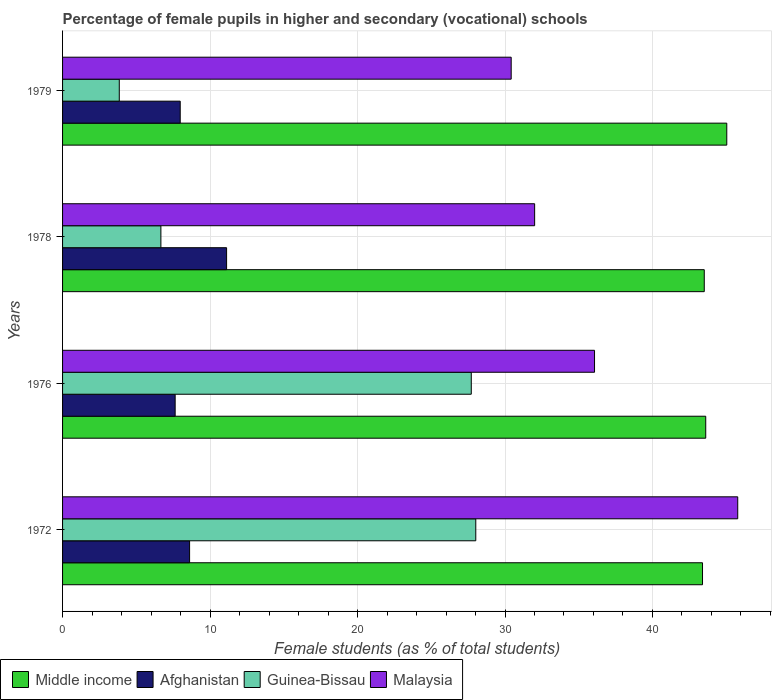Are the number of bars per tick equal to the number of legend labels?
Offer a very short reply. Yes. How many bars are there on the 4th tick from the bottom?
Provide a succinct answer. 4. What is the label of the 3rd group of bars from the top?
Offer a very short reply. 1976. In how many cases, is the number of bars for a given year not equal to the number of legend labels?
Ensure brevity in your answer.  0. What is the percentage of female pupils in higher and secondary schools in Middle income in 1976?
Offer a very short reply. 43.61. Across all years, what is the maximum percentage of female pupils in higher and secondary schools in Guinea-Bissau?
Offer a very short reply. 28.02. Across all years, what is the minimum percentage of female pupils in higher and secondary schools in Middle income?
Your response must be concise. 43.39. In which year was the percentage of female pupils in higher and secondary schools in Middle income maximum?
Your answer should be very brief. 1979. In which year was the percentage of female pupils in higher and secondary schools in Afghanistan minimum?
Provide a short and direct response. 1976. What is the total percentage of female pupils in higher and secondary schools in Malaysia in the graph?
Ensure brevity in your answer.  144.28. What is the difference between the percentage of female pupils in higher and secondary schools in Guinea-Bissau in 1972 and that in 1976?
Your answer should be compact. 0.31. What is the difference between the percentage of female pupils in higher and secondary schools in Guinea-Bissau in 1976 and the percentage of female pupils in higher and secondary schools in Afghanistan in 1972?
Your response must be concise. 19.1. What is the average percentage of female pupils in higher and secondary schools in Middle income per year?
Ensure brevity in your answer.  43.89. In the year 1978, what is the difference between the percentage of female pupils in higher and secondary schools in Middle income and percentage of female pupils in higher and secondary schools in Afghanistan?
Provide a succinct answer. 32.39. What is the ratio of the percentage of female pupils in higher and secondary schools in Guinea-Bissau in 1972 to that in 1978?
Keep it short and to the point. 4.2. Is the percentage of female pupils in higher and secondary schools in Malaysia in 1978 less than that in 1979?
Provide a short and direct response. No. Is the difference between the percentage of female pupils in higher and secondary schools in Middle income in 1972 and 1976 greater than the difference between the percentage of female pupils in higher and secondary schools in Afghanistan in 1972 and 1976?
Your response must be concise. No. What is the difference between the highest and the second highest percentage of female pupils in higher and secondary schools in Afghanistan?
Your answer should be compact. 2.51. What is the difference between the highest and the lowest percentage of female pupils in higher and secondary schools in Guinea-Bissau?
Keep it short and to the point. 24.17. In how many years, is the percentage of female pupils in higher and secondary schools in Malaysia greater than the average percentage of female pupils in higher and secondary schools in Malaysia taken over all years?
Your answer should be very brief. 2. Is the sum of the percentage of female pupils in higher and secondary schools in Malaysia in 1972 and 1976 greater than the maximum percentage of female pupils in higher and secondary schools in Guinea-Bissau across all years?
Offer a very short reply. Yes. Is it the case that in every year, the sum of the percentage of female pupils in higher and secondary schools in Guinea-Bissau and percentage of female pupils in higher and secondary schools in Afghanistan is greater than the sum of percentage of female pupils in higher and secondary schools in Malaysia and percentage of female pupils in higher and secondary schools in Middle income?
Offer a terse response. No. What does the 3rd bar from the top in 1972 represents?
Provide a short and direct response. Afghanistan. What does the 2nd bar from the bottom in 1979 represents?
Provide a succinct answer. Afghanistan. How many bars are there?
Your answer should be very brief. 16. What is the difference between two consecutive major ticks on the X-axis?
Give a very brief answer. 10. Does the graph contain grids?
Provide a succinct answer. Yes. How many legend labels are there?
Your answer should be very brief. 4. How are the legend labels stacked?
Offer a terse response. Horizontal. What is the title of the graph?
Offer a very short reply. Percentage of female pupils in higher and secondary (vocational) schools. Does "Tuvalu" appear as one of the legend labels in the graph?
Your answer should be very brief. No. What is the label or title of the X-axis?
Your answer should be compact. Female students (as % of total students). What is the label or title of the Y-axis?
Ensure brevity in your answer.  Years. What is the Female students (as % of total students) of Middle income in 1972?
Provide a short and direct response. 43.39. What is the Female students (as % of total students) in Afghanistan in 1972?
Ensure brevity in your answer.  8.61. What is the Female students (as % of total students) of Guinea-Bissau in 1972?
Make the answer very short. 28.02. What is the Female students (as % of total students) of Malaysia in 1972?
Your answer should be very brief. 45.78. What is the Female students (as % of total students) of Middle income in 1976?
Offer a very short reply. 43.61. What is the Female students (as % of total students) of Afghanistan in 1976?
Your answer should be compact. 7.63. What is the Female students (as % of total students) in Guinea-Bissau in 1976?
Your answer should be very brief. 27.71. What is the Female students (as % of total students) of Malaysia in 1976?
Give a very brief answer. 36.07. What is the Female students (as % of total students) in Middle income in 1978?
Give a very brief answer. 43.51. What is the Female students (as % of total students) of Afghanistan in 1978?
Keep it short and to the point. 11.12. What is the Female students (as % of total students) in Guinea-Bissau in 1978?
Offer a terse response. 6.67. What is the Female students (as % of total students) in Malaysia in 1978?
Give a very brief answer. 32.01. What is the Female students (as % of total students) of Middle income in 1979?
Offer a terse response. 45.04. What is the Female students (as % of total students) of Afghanistan in 1979?
Offer a terse response. 7.98. What is the Female students (as % of total students) in Guinea-Bissau in 1979?
Ensure brevity in your answer.  3.85. What is the Female students (as % of total students) of Malaysia in 1979?
Keep it short and to the point. 30.42. Across all years, what is the maximum Female students (as % of total students) of Middle income?
Give a very brief answer. 45.04. Across all years, what is the maximum Female students (as % of total students) in Afghanistan?
Provide a succinct answer. 11.12. Across all years, what is the maximum Female students (as % of total students) of Guinea-Bissau?
Offer a very short reply. 28.02. Across all years, what is the maximum Female students (as % of total students) of Malaysia?
Offer a terse response. 45.78. Across all years, what is the minimum Female students (as % of total students) of Middle income?
Provide a short and direct response. 43.39. Across all years, what is the minimum Female students (as % of total students) of Afghanistan?
Provide a short and direct response. 7.63. Across all years, what is the minimum Female students (as % of total students) in Guinea-Bissau?
Your answer should be compact. 3.85. Across all years, what is the minimum Female students (as % of total students) in Malaysia?
Offer a very short reply. 30.42. What is the total Female students (as % of total students) of Middle income in the graph?
Your answer should be compact. 175.56. What is the total Female students (as % of total students) in Afghanistan in the graph?
Keep it short and to the point. 35.35. What is the total Female students (as % of total students) of Guinea-Bissau in the graph?
Offer a terse response. 66.25. What is the total Female students (as % of total students) in Malaysia in the graph?
Provide a succinct answer. 144.28. What is the difference between the Female students (as % of total students) in Middle income in 1972 and that in 1976?
Keep it short and to the point. -0.22. What is the difference between the Female students (as % of total students) in Afghanistan in 1972 and that in 1976?
Make the answer very short. 0.98. What is the difference between the Female students (as % of total students) of Guinea-Bissau in 1972 and that in 1976?
Offer a terse response. 0.31. What is the difference between the Female students (as % of total students) in Malaysia in 1972 and that in 1976?
Your response must be concise. 9.71. What is the difference between the Female students (as % of total students) of Middle income in 1972 and that in 1978?
Your response must be concise. -0.12. What is the difference between the Female students (as % of total students) of Afghanistan in 1972 and that in 1978?
Provide a succinct answer. -2.51. What is the difference between the Female students (as % of total students) of Guinea-Bissau in 1972 and that in 1978?
Offer a very short reply. 21.35. What is the difference between the Female students (as % of total students) of Malaysia in 1972 and that in 1978?
Keep it short and to the point. 13.77. What is the difference between the Female students (as % of total students) of Middle income in 1972 and that in 1979?
Make the answer very short. -1.64. What is the difference between the Female students (as % of total students) in Afghanistan in 1972 and that in 1979?
Keep it short and to the point. 0.64. What is the difference between the Female students (as % of total students) of Guinea-Bissau in 1972 and that in 1979?
Your answer should be very brief. 24.17. What is the difference between the Female students (as % of total students) of Malaysia in 1972 and that in 1979?
Provide a succinct answer. 15.36. What is the difference between the Female students (as % of total students) in Middle income in 1976 and that in 1978?
Provide a succinct answer. 0.1. What is the difference between the Female students (as % of total students) of Afghanistan in 1976 and that in 1978?
Your answer should be compact. -3.49. What is the difference between the Female students (as % of total students) in Guinea-Bissau in 1976 and that in 1978?
Offer a very short reply. 21.05. What is the difference between the Female students (as % of total students) of Malaysia in 1976 and that in 1978?
Your response must be concise. 4.06. What is the difference between the Female students (as % of total students) in Middle income in 1976 and that in 1979?
Ensure brevity in your answer.  -1.43. What is the difference between the Female students (as % of total students) of Afghanistan in 1976 and that in 1979?
Keep it short and to the point. -0.34. What is the difference between the Female students (as % of total students) of Guinea-Bissau in 1976 and that in 1979?
Your answer should be compact. 23.87. What is the difference between the Female students (as % of total students) in Malaysia in 1976 and that in 1979?
Provide a succinct answer. 5.65. What is the difference between the Female students (as % of total students) in Middle income in 1978 and that in 1979?
Offer a terse response. -1.53. What is the difference between the Female students (as % of total students) of Afghanistan in 1978 and that in 1979?
Give a very brief answer. 3.14. What is the difference between the Female students (as % of total students) of Guinea-Bissau in 1978 and that in 1979?
Your response must be concise. 2.82. What is the difference between the Female students (as % of total students) in Malaysia in 1978 and that in 1979?
Make the answer very short. 1.59. What is the difference between the Female students (as % of total students) of Middle income in 1972 and the Female students (as % of total students) of Afghanistan in 1976?
Provide a short and direct response. 35.76. What is the difference between the Female students (as % of total students) in Middle income in 1972 and the Female students (as % of total students) in Guinea-Bissau in 1976?
Provide a short and direct response. 15.68. What is the difference between the Female students (as % of total students) in Middle income in 1972 and the Female students (as % of total students) in Malaysia in 1976?
Offer a terse response. 7.32. What is the difference between the Female students (as % of total students) of Afghanistan in 1972 and the Female students (as % of total students) of Guinea-Bissau in 1976?
Offer a terse response. -19.1. What is the difference between the Female students (as % of total students) of Afghanistan in 1972 and the Female students (as % of total students) of Malaysia in 1976?
Keep it short and to the point. -27.46. What is the difference between the Female students (as % of total students) of Guinea-Bissau in 1972 and the Female students (as % of total students) of Malaysia in 1976?
Provide a succinct answer. -8.05. What is the difference between the Female students (as % of total students) in Middle income in 1972 and the Female students (as % of total students) in Afghanistan in 1978?
Your answer should be compact. 32.27. What is the difference between the Female students (as % of total students) in Middle income in 1972 and the Female students (as % of total students) in Guinea-Bissau in 1978?
Your answer should be compact. 36.73. What is the difference between the Female students (as % of total students) of Middle income in 1972 and the Female students (as % of total students) of Malaysia in 1978?
Keep it short and to the point. 11.38. What is the difference between the Female students (as % of total students) of Afghanistan in 1972 and the Female students (as % of total students) of Guinea-Bissau in 1978?
Offer a very short reply. 1.95. What is the difference between the Female students (as % of total students) in Afghanistan in 1972 and the Female students (as % of total students) in Malaysia in 1978?
Your response must be concise. -23.4. What is the difference between the Female students (as % of total students) of Guinea-Bissau in 1972 and the Female students (as % of total students) of Malaysia in 1978?
Your answer should be compact. -3.99. What is the difference between the Female students (as % of total students) in Middle income in 1972 and the Female students (as % of total students) in Afghanistan in 1979?
Ensure brevity in your answer.  35.42. What is the difference between the Female students (as % of total students) in Middle income in 1972 and the Female students (as % of total students) in Guinea-Bissau in 1979?
Your response must be concise. 39.55. What is the difference between the Female students (as % of total students) of Middle income in 1972 and the Female students (as % of total students) of Malaysia in 1979?
Give a very brief answer. 12.97. What is the difference between the Female students (as % of total students) in Afghanistan in 1972 and the Female students (as % of total students) in Guinea-Bissau in 1979?
Your answer should be very brief. 4.77. What is the difference between the Female students (as % of total students) of Afghanistan in 1972 and the Female students (as % of total students) of Malaysia in 1979?
Provide a short and direct response. -21.81. What is the difference between the Female students (as % of total students) in Guinea-Bissau in 1972 and the Female students (as % of total students) in Malaysia in 1979?
Provide a short and direct response. -2.4. What is the difference between the Female students (as % of total students) of Middle income in 1976 and the Female students (as % of total students) of Afghanistan in 1978?
Offer a very short reply. 32.49. What is the difference between the Female students (as % of total students) of Middle income in 1976 and the Female students (as % of total students) of Guinea-Bissau in 1978?
Keep it short and to the point. 36.95. What is the difference between the Female students (as % of total students) in Middle income in 1976 and the Female students (as % of total students) in Malaysia in 1978?
Offer a very short reply. 11.6. What is the difference between the Female students (as % of total students) in Afghanistan in 1976 and the Female students (as % of total students) in Guinea-Bissau in 1978?
Offer a terse response. 0.97. What is the difference between the Female students (as % of total students) of Afghanistan in 1976 and the Female students (as % of total students) of Malaysia in 1978?
Your answer should be compact. -24.38. What is the difference between the Female students (as % of total students) in Guinea-Bissau in 1976 and the Female students (as % of total students) in Malaysia in 1978?
Provide a succinct answer. -4.3. What is the difference between the Female students (as % of total students) in Middle income in 1976 and the Female students (as % of total students) in Afghanistan in 1979?
Provide a succinct answer. 35.63. What is the difference between the Female students (as % of total students) of Middle income in 1976 and the Female students (as % of total students) of Guinea-Bissau in 1979?
Give a very brief answer. 39.77. What is the difference between the Female students (as % of total students) in Middle income in 1976 and the Female students (as % of total students) in Malaysia in 1979?
Make the answer very short. 13.19. What is the difference between the Female students (as % of total students) of Afghanistan in 1976 and the Female students (as % of total students) of Guinea-Bissau in 1979?
Give a very brief answer. 3.79. What is the difference between the Female students (as % of total students) in Afghanistan in 1976 and the Female students (as % of total students) in Malaysia in 1979?
Provide a succinct answer. -22.78. What is the difference between the Female students (as % of total students) of Guinea-Bissau in 1976 and the Female students (as % of total students) of Malaysia in 1979?
Offer a terse response. -2.71. What is the difference between the Female students (as % of total students) in Middle income in 1978 and the Female students (as % of total students) in Afghanistan in 1979?
Your answer should be compact. 35.53. What is the difference between the Female students (as % of total students) in Middle income in 1978 and the Female students (as % of total students) in Guinea-Bissau in 1979?
Make the answer very short. 39.67. What is the difference between the Female students (as % of total students) in Middle income in 1978 and the Female students (as % of total students) in Malaysia in 1979?
Your answer should be compact. 13.09. What is the difference between the Female students (as % of total students) in Afghanistan in 1978 and the Female students (as % of total students) in Guinea-Bissau in 1979?
Your answer should be very brief. 7.28. What is the difference between the Female students (as % of total students) in Afghanistan in 1978 and the Female students (as % of total students) in Malaysia in 1979?
Provide a succinct answer. -19.3. What is the difference between the Female students (as % of total students) in Guinea-Bissau in 1978 and the Female students (as % of total students) in Malaysia in 1979?
Your answer should be very brief. -23.75. What is the average Female students (as % of total students) of Middle income per year?
Offer a terse response. 43.89. What is the average Female students (as % of total students) in Afghanistan per year?
Ensure brevity in your answer.  8.84. What is the average Female students (as % of total students) of Guinea-Bissau per year?
Your answer should be very brief. 16.56. What is the average Female students (as % of total students) in Malaysia per year?
Offer a terse response. 36.07. In the year 1972, what is the difference between the Female students (as % of total students) of Middle income and Female students (as % of total students) of Afghanistan?
Give a very brief answer. 34.78. In the year 1972, what is the difference between the Female students (as % of total students) in Middle income and Female students (as % of total students) in Guinea-Bissau?
Ensure brevity in your answer.  15.37. In the year 1972, what is the difference between the Female students (as % of total students) of Middle income and Female students (as % of total students) of Malaysia?
Ensure brevity in your answer.  -2.39. In the year 1972, what is the difference between the Female students (as % of total students) in Afghanistan and Female students (as % of total students) in Guinea-Bissau?
Provide a succinct answer. -19.41. In the year 1972, what is the difference between the Female students (as % of total students) in Afghanistan and Female students (as % of total students) in Malaysia?
Your answer should be very brief. -37.17. In the year 1972, what is the difference between the Female students (as % of total students) of Guinea-Bissau and Female students (as % of total students) of Malaysia?
Offer a very short reply. -17.76. In the year 1976, what is the difference between the Female students (as % of total students) of Middle income and Female students (as % of total students) of Afghanistan?
Offer a terse response. 35.98. In the year 1976, what is the difference between the Female students (as % of total students) in Middle income and Female students (as % of total students) in Guinea-Bissau?
Offer a terse response. 15.9. In the year 1976, what is the difference between the Female students (as % of total students) of Middle income and Female students (as % of total students) of Malaysia?
Offer a very short reply. 7.54. In the year 1976, what is the difference between the Female students (as % of total students) in Afghanistan and Female students (as % of total students) in Guinea-Bissau?
Your answer should be very brief. -20.08. In the year 1976, what is the difference between the Female students (as % of total students) of Afghanistan and Female students (as % of total students) of Malaysia?
Offer a terse response. -28.44. In the year 1976, what is the difference between the Female students (as % of total students) of Guinea-Bissau and Female students (as % of total students) of Malaysia?
Your response must be concise. -8.36. In the year 1978, what is the difference between the Female students (as % of total students) of Middle income and Female students (as % of total students) of Afghanistan?
Offer a very short reply. 32.39. In the year 1978, what is the difference between the Female students (as % of total students) of Middle income and Female students (as % of total students) of Guinea-Bissau?
Offer a terse response. 36.85. In the year 1978, what is the difference between the Female students (as % of total students) of Middle income and Female students (as % of total students) of Malaysia?
Provide a short and direct response. 11.5. In the year 1978, what is the difference between the Female students (as % of total students) in Afghanistan and Female students (as % of total students) in Guinea-Bissau?
Offer a terse response. 4.46. In the year 1978, what is the difference between the Female students (as % of total students) of Afghanistan and Female students (as % of total students) of Malaysia?
Ensure brevity in your answer.  -20.89. In the year 1978, what is the difference between the Female students (as % of total students) in Guinea-Bissau and Female students (as % of total students) in Malaysia?
Your answer should be very brief. -25.34. In the year 1979, what is the difference between the Female students (as % of total students) of Middle income and Female students (as % of total students) of Afghanistan?
Offer a terse response. 37.06. In the year 1979, what is the difference between the Female students (as % of total students) of Middle income and Female students (as % of total students) of Guinea-Bissau?
Keep it short and to the point. 41.19. In the year 1979, what is the difference between the Female students (as % of total students) of Middle income and Female students (as % of total students) of Malaysia?
Make the answer very short. 14.62. In the year 1979, what is the difference between the Female students (as % of total students) of Afghanistan and Female students (as % of total students) of Guinea-Bissau?
Your response must be concise. 4.13. In the year 1979, what is the difference between the Female students (as % of total students) in Afghanistan and Female students (as % of total students) in Malaysia?
Ensure brevity in your answer.  -22.44. In the year 1979, what is the difference between the Female students (as % of total students) in Guinea-Bissau and Female students (as % of total students) in Malaysia?
Make the answer very short. -26.57. What is the ratio of the Female students (as % of total students) of Afghanistan in 1972 to that in 1976?
Your answer should be very brief. 1.13. What is the ratio of the Female students (as % of total students) in Malaysia in 1972 to that in 1976?
Your answer should be compact. 1.27. What is the ratio of the Female students (as % of total students) of Afghanistan in 1972 to that in 1978?
Your answer should be compact. 0.77. What is the ratio of the Female students (as % of total students) of Guinea-Bissau in 1972 to that in 1978?
Your answer should be compact. 4.2. What is the ratio of the Female students (as % of total students) of Malaysia in 1972 to that in 1978?
Ensure brevity in your answer.  1.43. What is the ratio of the Female students (as % of total students) in Middle income in 1972 to that in 1979?
Your answer should be very brief. 0.96. What is the ratio of the Female students (as % of total students) of Afghanistan in 1972 to that in 1979?
Give a very brief answer. 1.08. What is the ratio of the Female students (as % of total students) in Guinea-Bissau in 1972 to that in 1979?
Offer a very short reply. 7.29. What is the ratio of the Female students (as % of total students) in Malaysia in 1972 to that in 1979?
Your response must be concise. 1.5. What is the ratio of the Female students (as % of total students) of Middle income in 1976 to that in 1978?
Provide a short and direct response. 1. What is the ratio of the Female students (as % of total students) of Afghanistan in 1976 to that in 1978?
Your response must be concise. 0.69. What is the ratio of the Female students (as % of total students) of Guinea-Bissau in 1976 to that in 1978?
Give a very brief answer. 4.16. What is the ratio of the Female students (as % of total students) of Malaysia in 1976 to that in 1978?
Your response must be concise. 1.13. What is the ratio of the Female students (as % of total students) in Middle income in 1976 to that in 1979?
Keep it short and to the point. 0.97. What is the ratio of the Female students (as % of total students) in Afghanistan in 1976 to that in 1979?
Provide a short and direct response. 0.96. What is the ratio of the Female students (as % of total students) of Guinea-Bissau in 1976 to that in 1979?
Offer a very short reply. 7.21. What is the ratio of the Female students (as % of total students) in Malaysia in 1976 to that in 1979?
Offer a very short reply. 1.19. What is the ratio of the Female students (as % of total students) in Middle income in 1978 to that in 1979?
Your response must be concise. 0.97. What is the ratio of the Female students (as % of total students) of Afghanistan in 1978 to that in 1979?
Make the answer very short. 1.39. What is the ratio of the Female students (as % of total students) of Guinea-Bissau in 1978 to that in 1979?
Your answer should be compact. 1.73. What is the ratio of the Female students (as % of total students) in Malaysia in 1978 to that in 1979?
Your answer should be compact. 1.05. What is the difference between the highest and the second highest Female students (as % of total students) in Middle income?
Your response must be concise. 1.43. What is the difference between the highest and the second highest Female students (as % of total students) in Afghanistan?
Ensure brevity in your answer.  2.51. What is the difference between the highest and the second highest Female students (as % of total students) in Guinea-Bissau?
Offer a terse response. 0.31. What is the difference between the highest and the second highest Female students (as % of total students) in Malaysia?
Your response must be concise. 9.71. What is the difference between the highest and the lowest Female students (as % of total students) in Middle income?
Offer a terse response. 1.64. What is the difference between the highest and the lowest Female students (as % of total students) of Afghanistan?
Offer a terse response. 3.49. What is the difference between the highest and the lowest Female students (as % of total students) in Guinea-Bissau?
Your answer should be very brief. 24.17. What is the difference between the highest and the lowest Female students (as % of total students) of Malaysia?
Your answer should be compact. 15.36. 